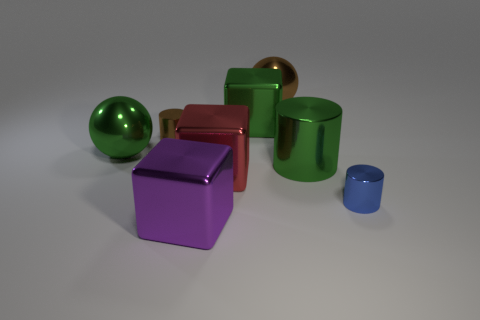What is the material of the big cube that is the same color as the big cylinder?
Provide a succinct answer. Metal. Is the green thing right of the big green block made of the same material as the ball in front of the large green block?
Give a very brief answer. Yes. There is a shiny sphere that is right of the cube that is behind the large shiny cylinder; how big is it?
Your response must be concise. Large. Are there any other things that have the same size as the green block?
Ensure brevity in your answer.  Yes. What material is the red object that is the same shape as the large purple metal thing?
Your answer should be very brief. Metal. Do the tiny thing that is to the left of the purple cube and the small blue object that is to the right of the red cube have the same shape?
Your answer should be very brief. Yes. Are there more brown objects than big brown things?
Your answer should be compact. Yes. How big is the blue thing?
Your answer should be compact. Small. How many other things are there of the same color as the big cylinder?
Your answer should be very brief. 2. Are the brown object that is on the right side of the purple metal block and the big green sphere made of the same material?
Make the answer very short. Yes. 